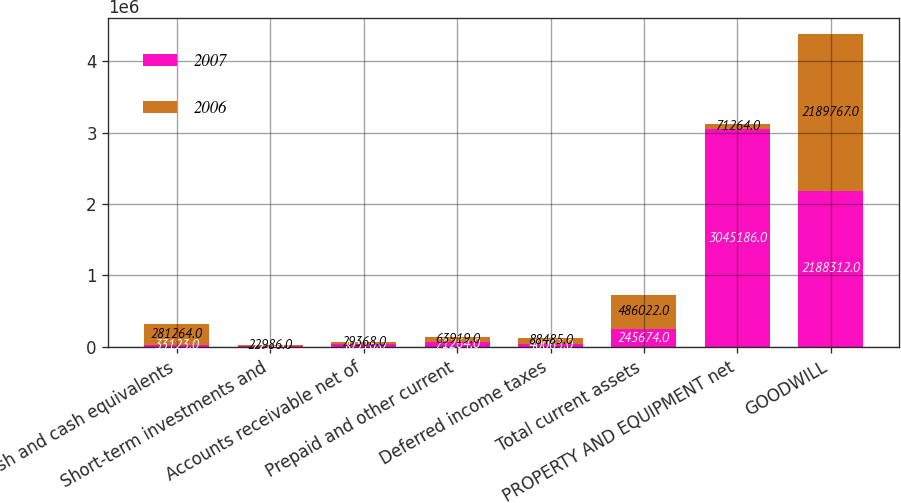Convert chart. <chart><loc_0><loc_0><loc_500><loc_500><stacked_bar_chart><ecel><fcel>Cash and cash equivalents<fcel>Short-term investments and<fcel>Accounts receivable net of<fcel>Prepaid and other current<fcel>Deferred income taxes<fcel>Total current assets<fcel>PROPERTY AND EQUIPMENT net<fcel>GOODWILL<nl><fcel>2007<fcel>33123<fcel>7224<fcel>40316<fcel>71264<fcel>40063<fcel>245674<fcel>3.04519e+06<fcel>2.18831e+06<nl><fcel>2006<fcel>281264<fcel>22986<fcel>29368<fcel>63919<fcel>88485<fcel>486022<fcel>71264<fcel>2.18977e+06<nl></chart> 